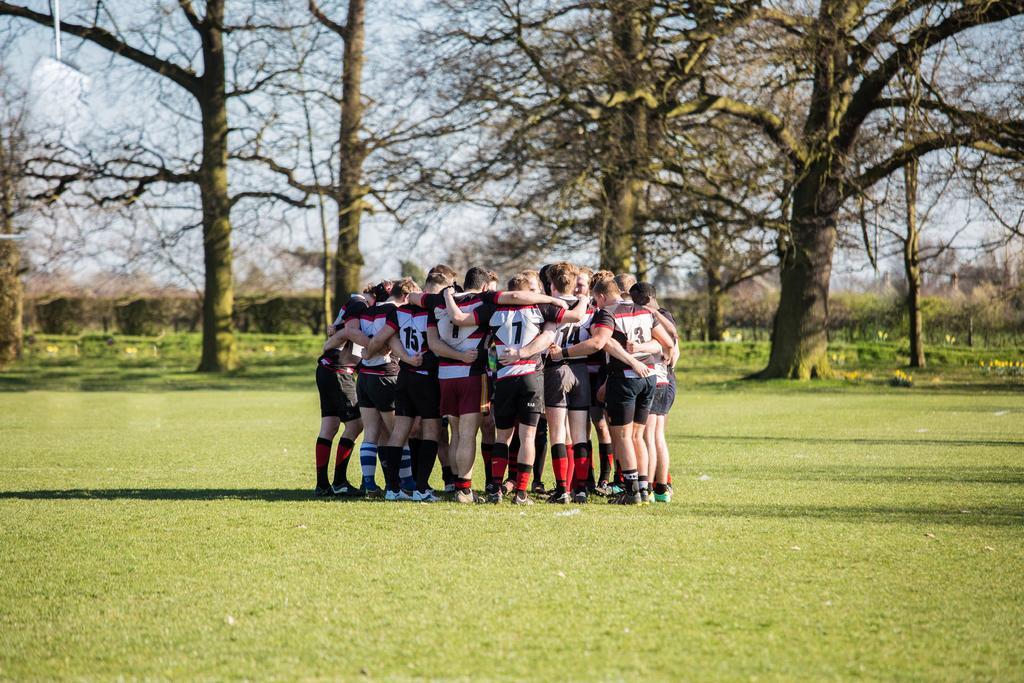What is the main subject of the image? There is a group of boys in the center of the image. Where are the boys located? The boys are on a grassland. What can be seen in the background of the image? There are trees in the background of the image. How does the committee help the boys in the image? There is no committee present in the image, so it cannot help the boys. 